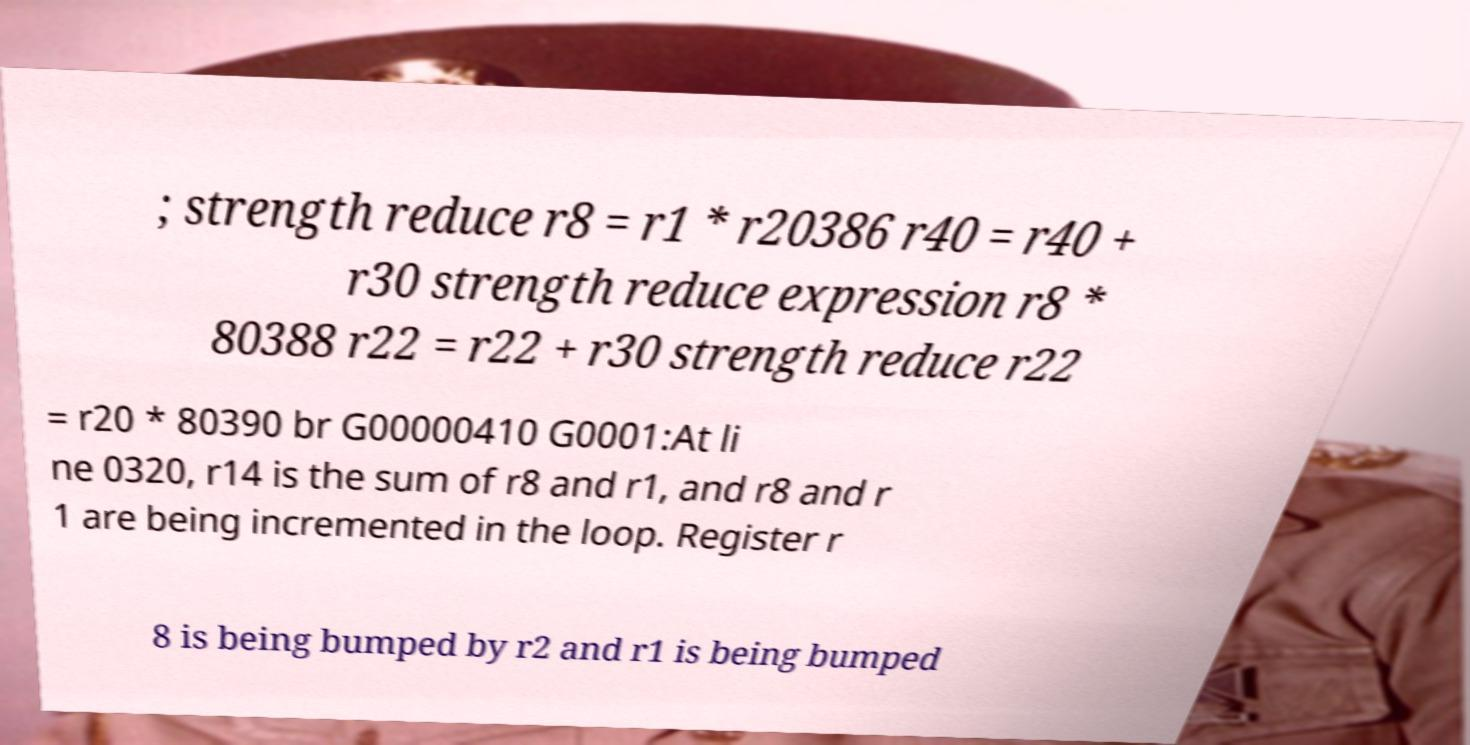Could you extract and type out the text from this image? ; strength reduce r8 = r1 * r20386 r40 = r40 + r30 strength reduce expression r8 * 80388 r22 = r22 + r30 strength reduce r22 = r20 * 80390 br G00000410 G0001:At li ne 0320, r14 is the sum of r8 and r1, and r8 and r 1 are being incremented in the loop. Register r 8 is being bumped by r2 and r1 is being bumped 